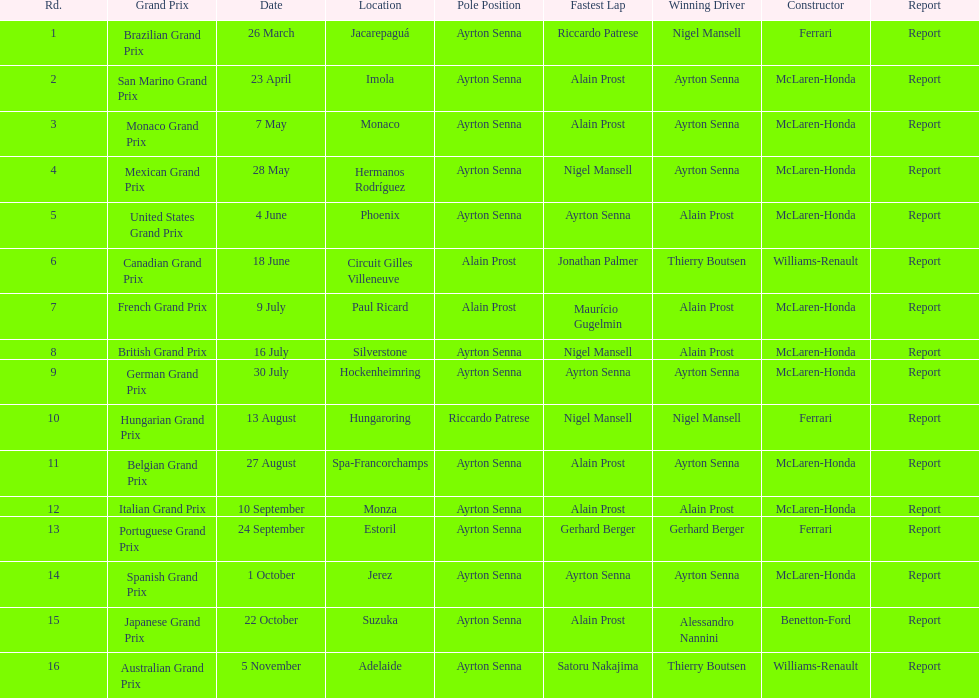Which grand prix occurred prior to the san marino grand prix? Brazilian Grand Prix. 